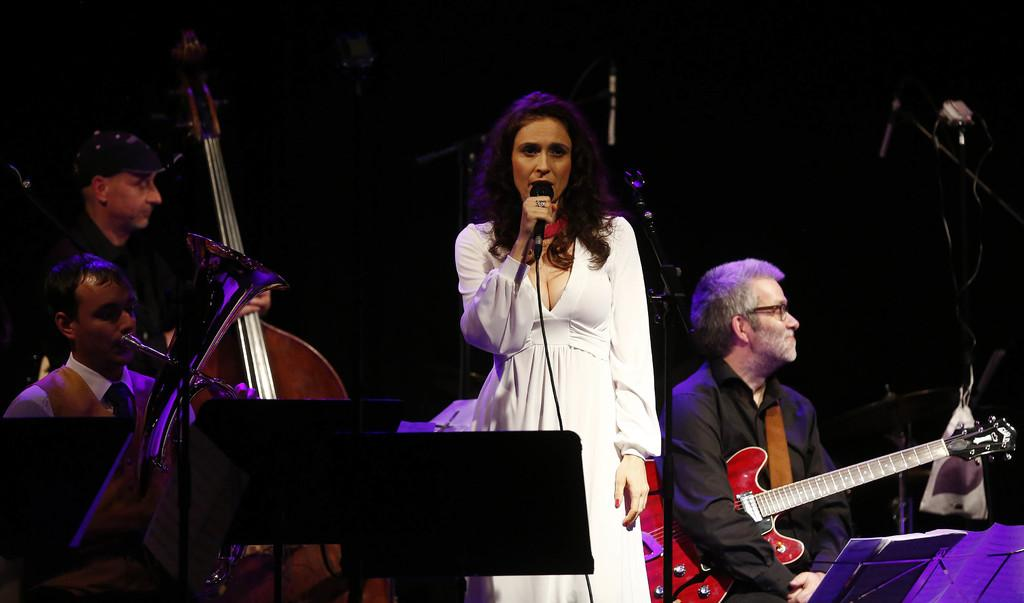Who is the main subject in the image? There is a lady in the image. What is the lady wearing? The lady is wearing a white frock. What is the lady holding in the image? A: The lady is holding a microphone. How many people are present in the image? There are three people in the image. What are the other two people doing in the image? The other two people are playing musical instruments. What type of alarm can be heard in the image? There is no alarm present in the image; it is a still image. 